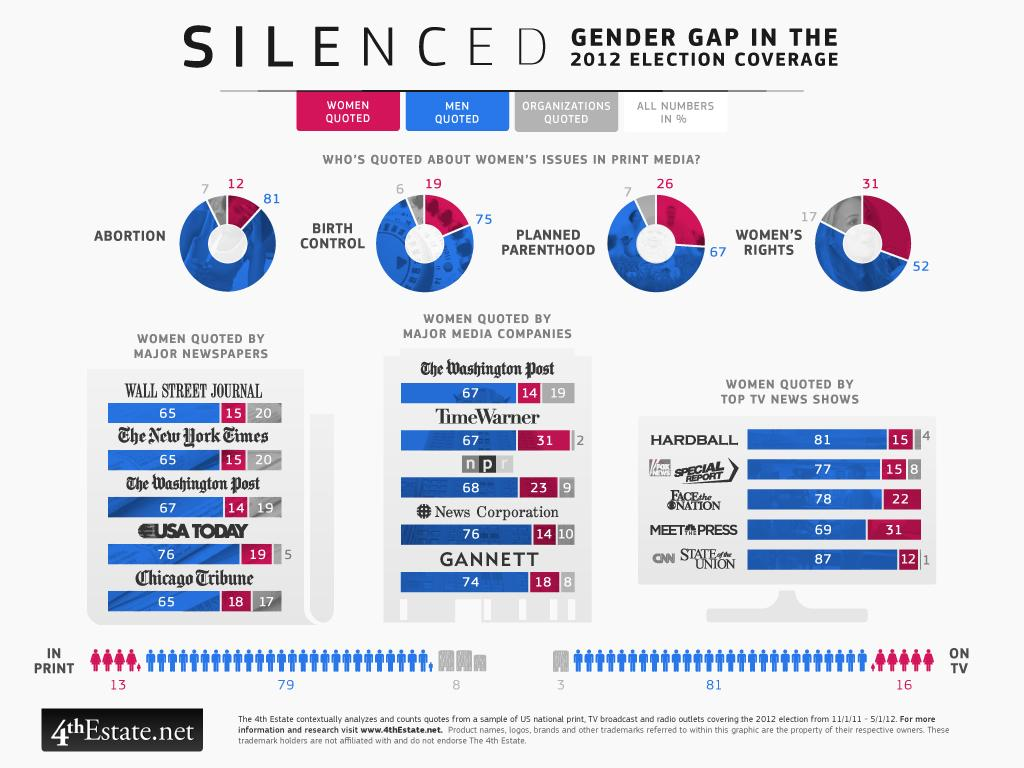Indicate a few pertinent items in this graphic. The television news show that mentioned women the most in their 2012 election coverage was 31.. There are 16 mentions of women in TV, but not 8 or 3 or 81. Organizations are featured least in print media when compared to men and women. There were 12 mentions of abortion by women in the media across the four dates specified: March 31, April 26, May 19, and June 12. Organizations are quoted by media outlets an average of two times or less. 